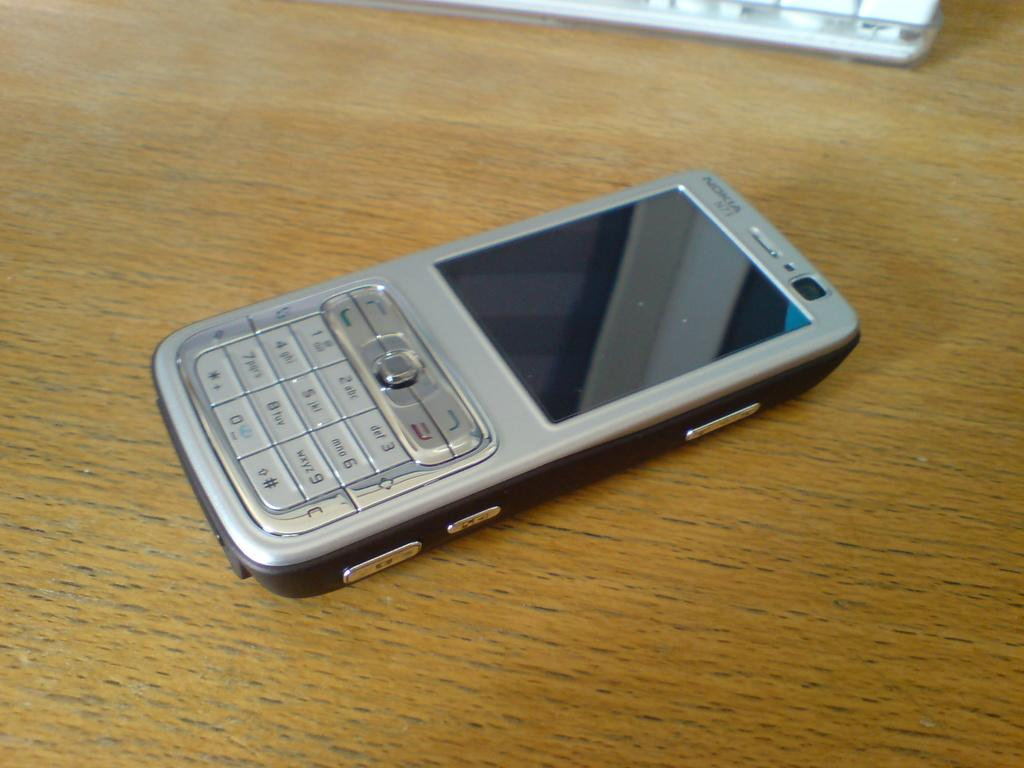Provide a one-sentence caption for the provided image. A Nokia cell phone sits on a wood table. 